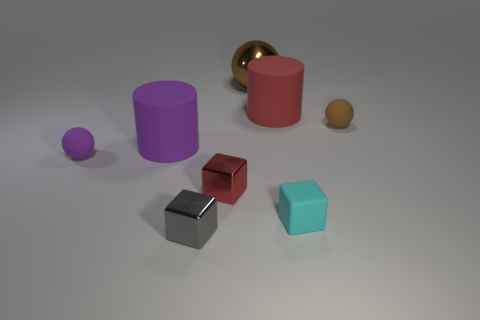Add 1 purple objects. How many objects exist? 9 Subtract all cubes. How many objects are left? 5 Add 5 red matte cylinders. How many red matte cylinders are left? 6 Add 7 rubber balls. How many rubber balls exist? 9 Subtract 0 gray cylinders. How many objects are left? 8 Subtract all brown balls. Subtract all small gray metal things. How many objects are left? 5 